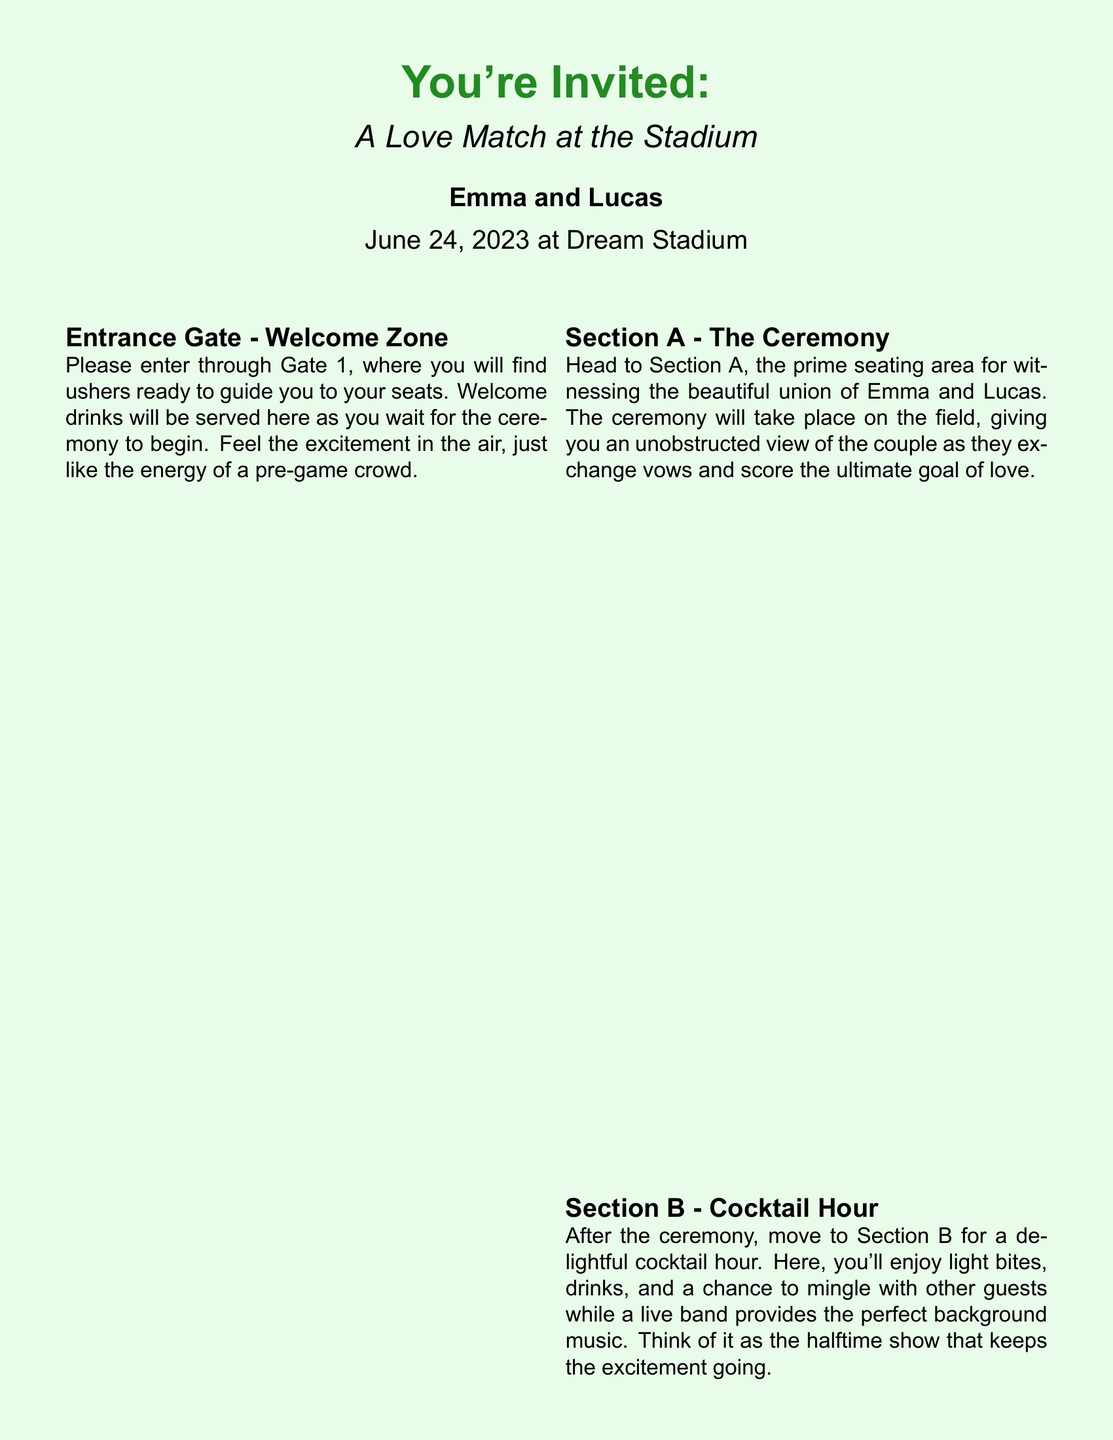What is the date of the wedding? The date of the wedding is clearly stated in the invitation, which is June 24, 2023.
Answer: June 24, 2023 What section hosts the ceremony? The document specifies that the ceremony takes place in Section A.
Answer: Section A What type of event follows the ceremony? According to the invitation, the cocktail hour follows the ceremony and is located in Section B.
Answer: Cocktail Hour How many sections are outlined in the document? The invitation details a total of five distinct areas for the event, including the entrance and exit zones.
Answer: Five What color is the page background? The background color of the page is described in the document as light green.
Answer: Light green What should guests use to exit the event? The document indicates that guests should exit through Gate 5.
Answer: Gate 5 What is promised regarding the event's outcome? The document humorously states that, unlike the Orlando Pride, there will be plenty of wins and no disappointments at this event.
Answer: Plenty of wins What will be served at the cocktail hour? The invitation mentions that light bites and drinks will be served during the cocktail hour.
Answer: Light bites and drinks What music will be played in Section D? The DJ will spin tunes in Section D to keep guests entertained on the dance floor.
Answer: DJ tunes 